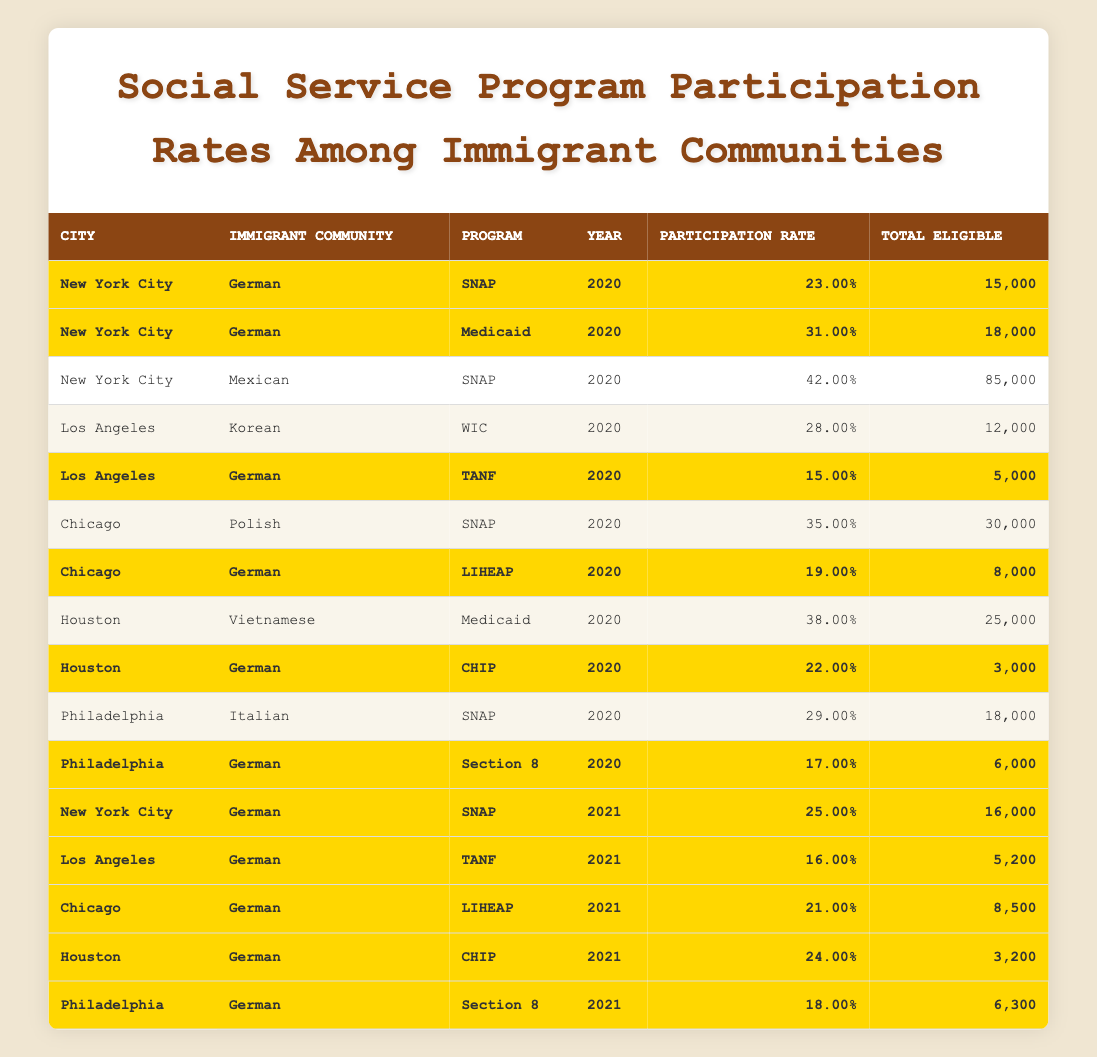What was the participation rate for the German community in the SNAP program in New York City in 2020? The table shows that in 2020, the participation rate for the German community in the SNAP program in New York City was 23%.
Answer: 23% Which immigrant community had the highest SNAP participation rate in 2020? Looking through the table, the Mexican community had a SNAP participation rate of 42% in New York City in 2020, which is the highest among all listed communities.
Answer: Mexican What is the total number of eligible individuals for the TANF program in Los Angeles for the German community in 2021? The table indicates that in 2021, the total number of eligible individuals for the TANF program in Los Angeles for the German community was 5,200.
Answer: 5,200 In which year did the German community have the highest SNAP participation rate in New York City? The table shows that in 2021, the German community had a SNAP participation rate of 25%, which is higher than 23% in 2020. Thus, 2021 is the year with the highest participation rate.
Answer: 2021 What is the average participation rate for the German community across all programs in 2020? We can calculate this by taking the participation rates of the German community across all listed programs in 2020, which are 23%, 31%, 15%, 19%, 22%, and 17%. Summing these values gives 23 + 31 + 15 + 19 + 22 + 17 = 127, and dividing by the number of programs (5) gives an average participation rate of 127 / 5 = 21.4%.
Answer: 21.4% Did any city report a Medicaid participation rate higher than 30% for the German immigrant community in 2020? According to the data in the table, only New York City reported a Medicaid participation rate of 31% for the German community in 2020, which is indeed higher than 30%.
Answer: Yes How many more eligible individuals were there for SNAP among the Mexican community compared to the German community in New York City in 2020? The total eligible individuals for the Mexican community in SNAP was 85,000, while for the German community, it was 15,000. The difference is 85,000 - 15,000 = 70,000 more eligible individuals for the Mexican community.
Answer: 70,000 Did the participation rate for the German community in CHIP increase from 2020 to 2021? In 2020, the participation rate for the German community in CHIP was 22% and increased to 24% in 2021. Therefore, the participation rate did indeed increase.
Answer: Yes How many total eligible individuals were there for Section 8 in Philadelphia for the German community across 2020 and 2021? According to the table, the total eligible individuals for Section 8 in Philadelphia for the German community in 2020 was 6,000 and in 2021 was 6,300. Adding these gives 6,000 + 6,300 = 12,300 total eligible individuals across both years.
Answer: 12,300 